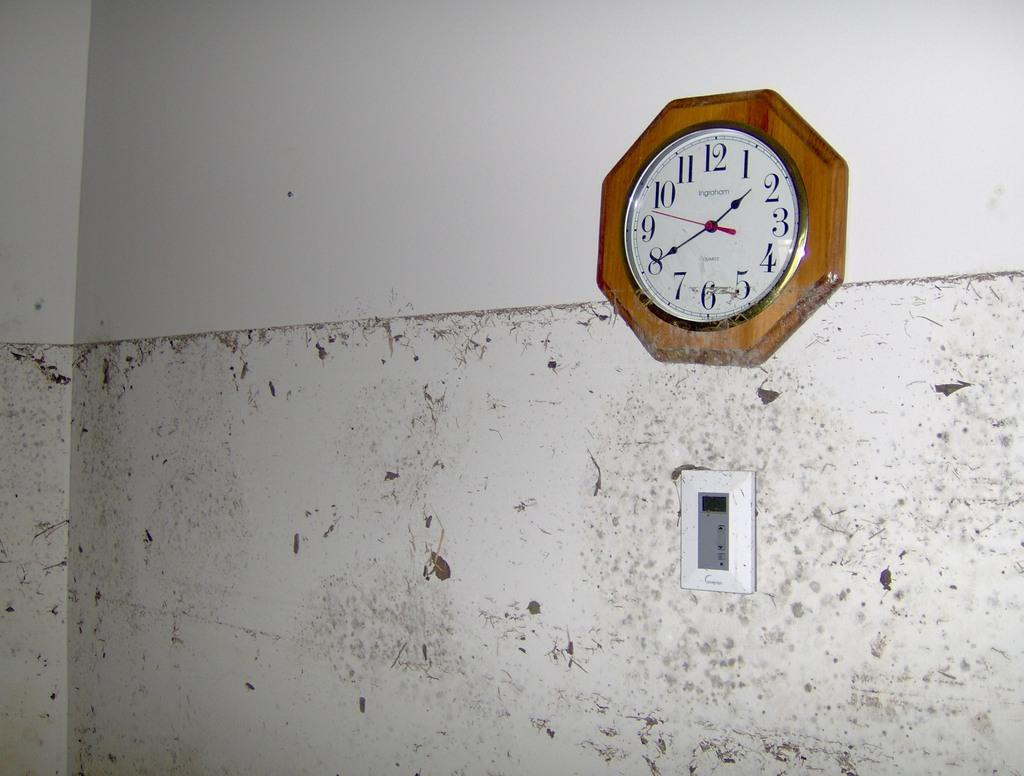Provide a one-sentence caption for the provided image. A clock made by Ingraham shows that it is 1:40. 